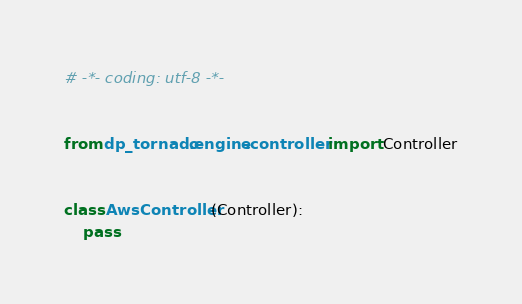Convert code to text. <code><loc_0><loc_0><loc_500><loc_500><_Python_># -*- coding: utf-8 -*-


from dp_tornado.engine.controller import Controller


class AwsController(Controller):
    pass
</code> 